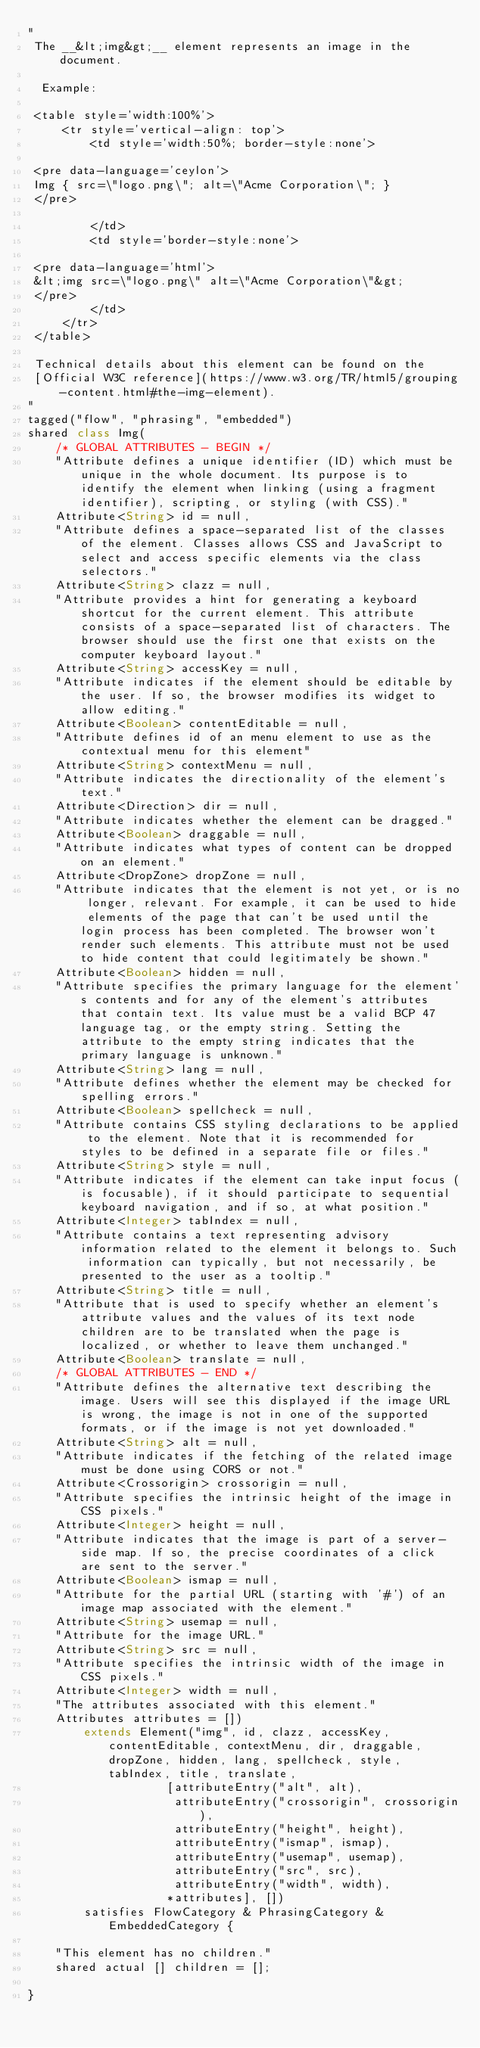Convert code to text. <code><loc_0><loc_0><loc_500><loc_500><_Ceylon_>"
 The __&lt;img&gt;__ element represents an image in the document.
 
  Example:
 
 <table style='width:100%'>
     <tr style='vertical-align: top'>
         <td style='width:50%; border-style:none'>
         
 <pre data-language='ceylon'>
 Img { src=\"logo.png\"; alt=\"Acme Corporation\"; }
 </pre>
 
         </td>
         <td style='border-style:none'>
         
 <pre data-language='html'>
 &lt;img src=\"logo.png\" alt=\"Acme Corporation\"&gt;
 </pre>
         </td>         
     </tr>
 </table>
 
 Technical details about this element can be found on the
 [Official W3C reference](https://www.w3.org/TR/html5/grouping-content.html#the-img-element).
"
tagged("flow", "phrasing", "embedded")
shared class Img(
    /* GLOBAL ATTRIBUTES - BEGIN */
    "Attribute defines a unique identifier (ID) which must be unique in the whole document. Its purpose is to identify the element when linking (using a fragment identifier), scripting, or styling (with CSS)."
    Attribute<String> id = null,
    "Attribute defines a space-separated list of the classes of the element. Classes allows CSS and JavaScript to select and access specific elements via the class selectors."
    Attribute<String> clazz = null,
    "Attribute provides a hint for generating a keyboard shortcut for the current element. This attribute consists of a space-separated list of characters. The browser should use the first one that exists on the computer keyboard layout."
    Attribute<String> accessKey = null,
    "Attribute indicates if the element should be editable by the user. If so, the browser modifies its widget to allow editing."
    Attribute<Boolean> contentEditable = null,
    "Attribute defines id of an menu element to use as the contextual menu for this element"
    Attribute<String> contextMenu = null,
    "Attribute indicates the directionality of the element's text."
    Attribute<Direction> dir = null,
    "Attribute indicates whether the element can be dragged."
    Attribute<Boolean> draggable = null,
    "Attribute indicates what types of content can be dropped on an element."
    Attribute<DropZone> dropZone = null,
    "Attribute indicates that the element is not yet, or is no longer, relevant. For example, it can be used to hide elements of the page that can't be used until the login process has been completed. The browser won't render such elements. This attribute must not be used to hide content that could legitimately be shown."
    Attribute<Boolean> hidden = null,
    "Attribute specifies the primary language for the element's contents and for any of the element's attributes that contain text. Its value must be a valid BCP 47 language tag, or the empty string. Setting the attribute to the empty string indicates that the primary language is unknown."
    Attribute<String> lang = null,
    "Attribute defines whether the element may be checked for spelling errors."
    Attribute<Boolean> spellcheck = null,
    "Attribute contains CSS styling declarations to be applied to the element. Note that it is recommended for styles to be defined in a separate file or files."
    Attribute<String> style = null,
    "Attribute indicates if the element can take input focus (is focusable), if it should participate to sequential keyboard navigation, and if so, at what position."
    Attribute<Integer> tabIndex = null,
    "Attribute contains a text representing advisory information related to the element it belongs to. Such information can typically, but not necessarily, be presented to the user as a tooltip."
    Attribute<String> title = null,
    "Attribute that is used to specify whether an element's attribute values and the values of its text node children are to be translated when the page is localized, or whether to leave them unchanged."
    Attribute<Boolean> translate = null,
    /* GLOBAL ATTRIBUTES - END */
    "Attribute defines the alternative text describing the image. Users will see this displayed if the image URL is wrong, the image is not in one of the supported formats, or if the image is not yet downloaded."
    Attribute<String> alt = null,
    "Attribute indicates if the fetching of the related image must be done using CORS or not."
    Attribute<Crossorigin> crossorigin = null,
    "Attribute specifies the intrinsic height of the image in CSS pixels."
    Attribute<Integer> height = null,
    "Attribute indicates that the image is part of a server-side map. If so, the precise coordinates of a click are sent to the server."
    Attribute<Boolean> ismap = null,
    "Attribute for the partial URL (starting with '#') of an image map associated with the element."
    Attribute<String> usemap = null,
    "Attribute for the image URL."
    Attribute<String> src = null,
    "Attribute specifies the intrinsic width of the image in CSS pixels."
    Attribute<Integer> width = null,
    "The attributes associated with this element."
    Attributes attributes = [])
        extends Element("img", id, clazz, accessKey, contentEditable, contextMenu, dir, draggable, dropZone, hidden, lang, spellcheck, style, tabIndex, title, translate, 
                    [attributeEntry("alt", alt),
                     attributeEntry("crossorigin", crossorigin),
                     attributeEntry("height", height),
                     attributeEntry("ismap", ismap),
                     attributeEntry("usemap", usemap),
                     attributeEntry("src", src),
                     attributeEntry("width", width),
                    *attributes], [])
        satisfies FlowCategory & PhrasingCategory & EmbeddedCategory {
    
    "This element has no children."
    shared actual [] children = [];
    
}</code> 